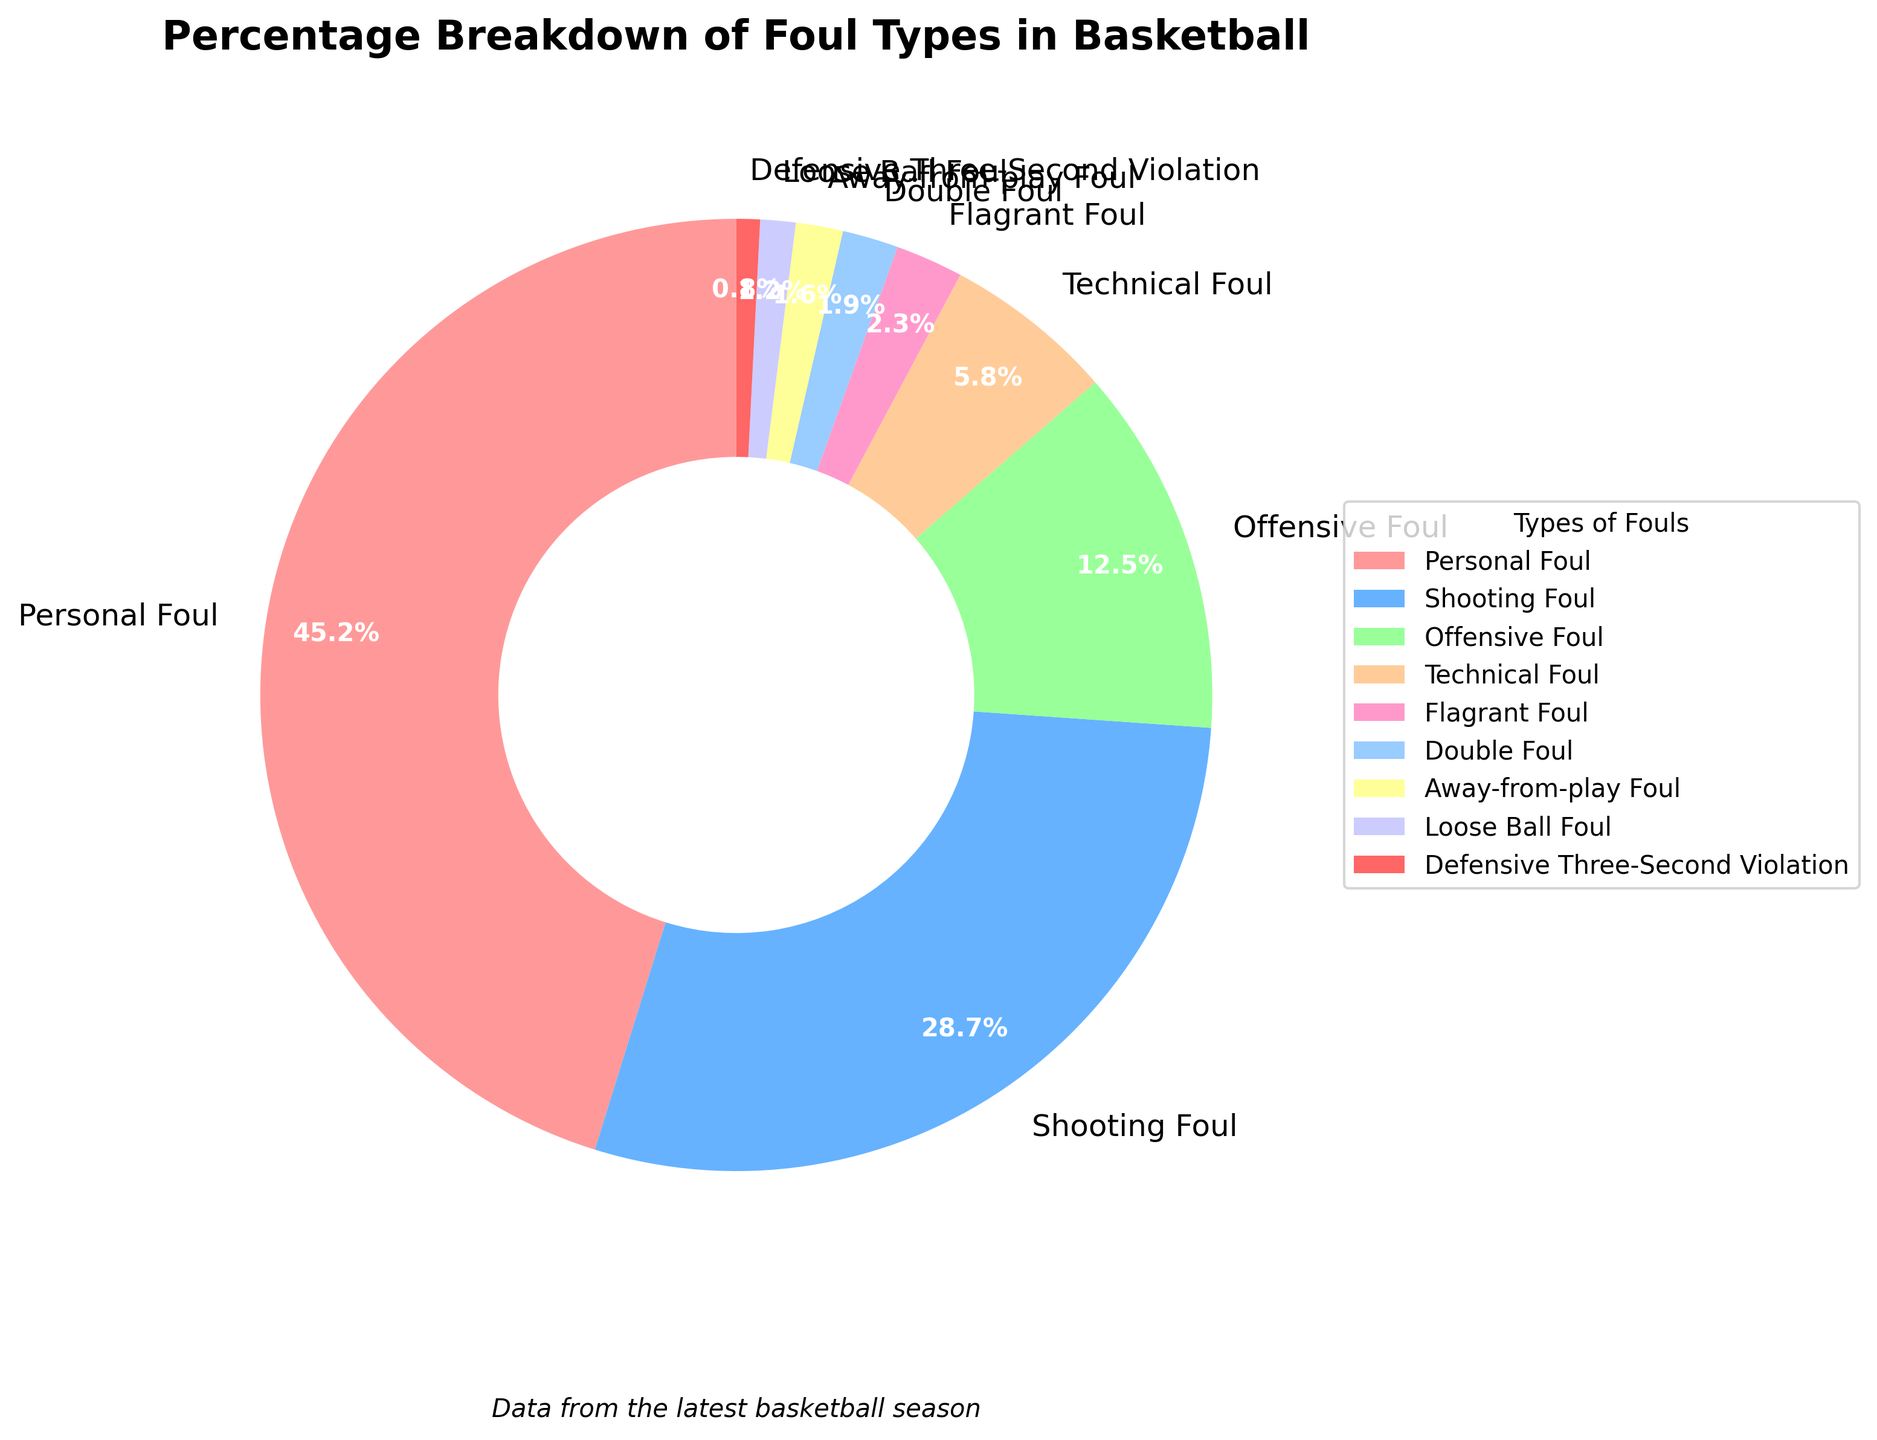What is the most common type of foul committed in the basketball season? By looking at the largest segment in the pie chart, we can see which type of foul has the highest percentage. The "Personal Foul" segment is clearly the largest.
Answer: Personal Foul How much more common is a Personal Foul compared to a Technical Foul? Find the percentages for Personal Foul and Technical Foul from the chart. Personal Foul is 45.2% and Technical Foul is 5.8%. Subtract 5.8% from 45.2% to find the difference.
Answer: 39.4% Which two types of fouls together make up over half of the total fouls? Identify the two largest segments and add their percentages. Personal Foul is 45.2% and Shooting Foul is 28.7%. Their sum is 73.9%, which is more than half.
Answer: Personal Foul and Shooting Foul Compare the sum of Offensive Foul and Technical Foul percentages to the sum of Flagrant Foul and Double Foul percentages. Which sum is greater? Calculate both sums: Offensive Foul (12.5%) + Technical Foul (5.8%) = 18.3%, and Flagrant Foul (2.3%) + Double Foul (1.9%) = 4.2%. Compare the results.
Answer: Offensive Foul and Technical Foul What is the combined percentage of the least common three types of fouls? Identify the three smallest percentages in the chart: Defensive Three-Second Violation (0.8%), Loose Ball Foul (1.2%), and Away-from-play Foul (1.6%). Add these percentages together: 0.8% + 1.2% + 1.6% = 3.6%.
Answer: 3.6% Which foul type is represented by the green segment in the chart? Refer to the legend in the pie chart, where each segment's color corresponds to a foul type. The green segment can be identified as Shooting Foul.
Answer: Shooting Foul Are Offensive Fouls more common than Flagrant Fouls? Compare the percentages. Offensive Foul is 12.5%, while Flagrant Foul is 2.3%. Offensive Foul has a higher percentage.
Answer: Yes What is the difference in percentage between the Away-from-play Foul and Loose Ball Foul? Subtract the smaller percentage (Loose Ball Foul: 1.2%) from the larger percentage (Away-from-play Foul: 1.6%). 1.6% - 1.2% = 0.4%.
Answer: 0.4% 